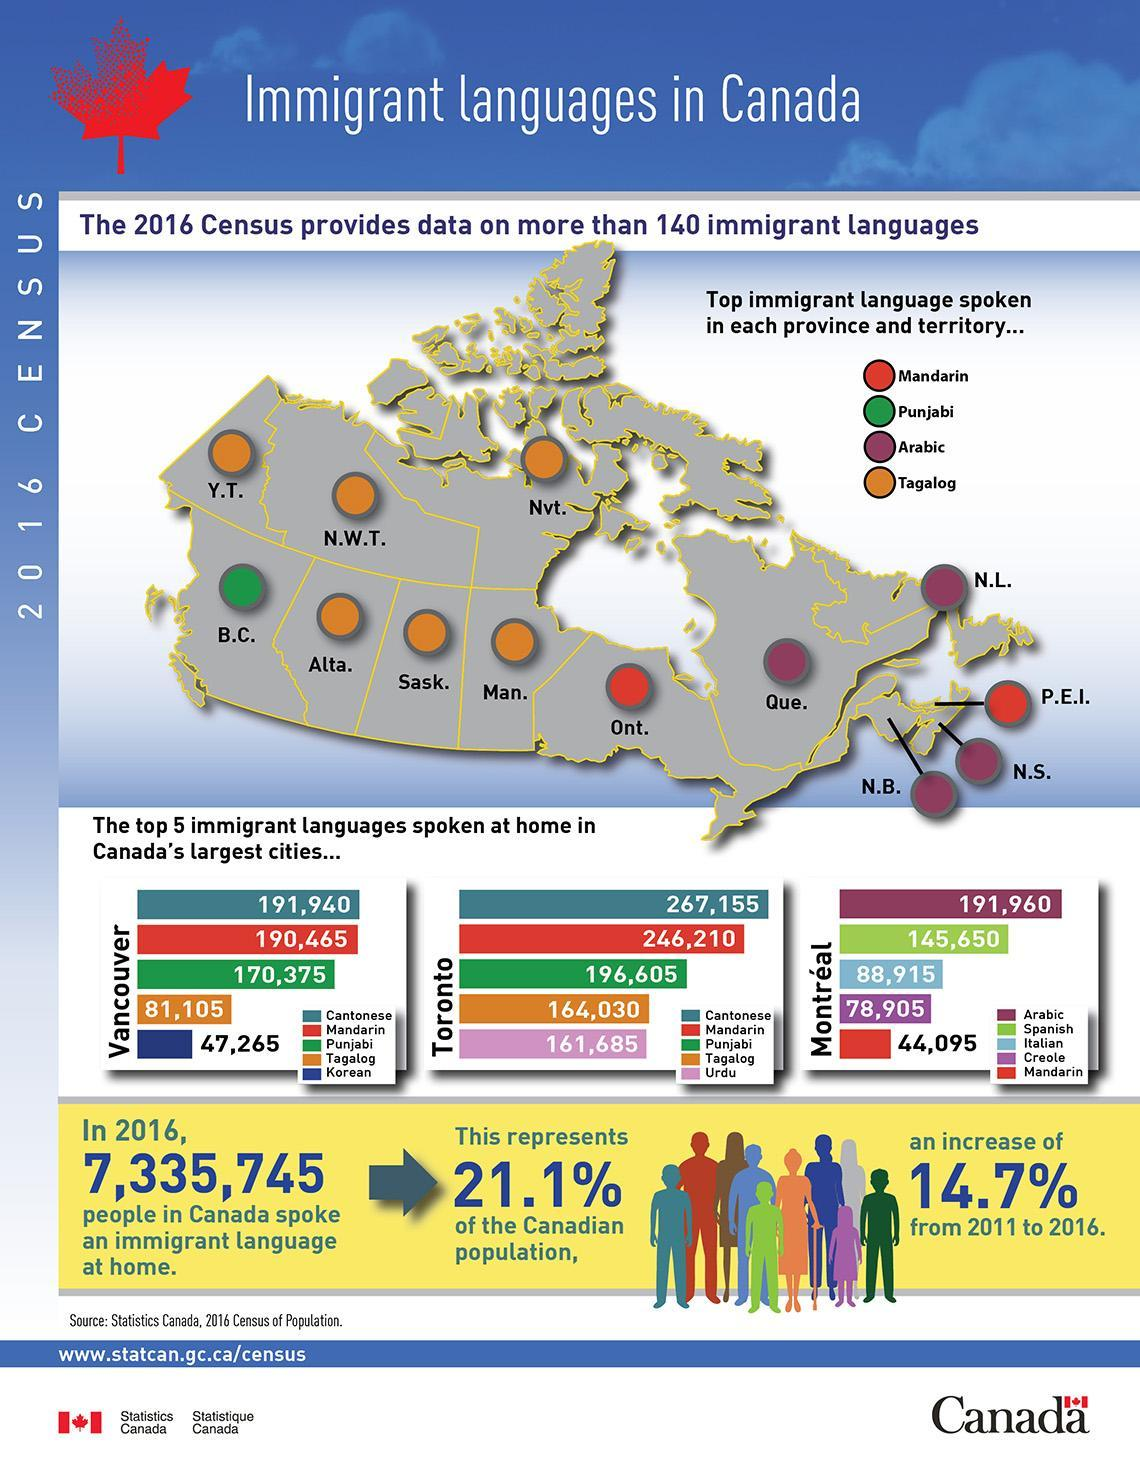How many states have Mandarin as an immigrant language?
Answer the question with a short phrase. 2 How many states have Tagalog as an immigrant language? 6 How many states have Punjabi as an immigrant language? 1 How many states have Arabic as an immigrant language? 4 